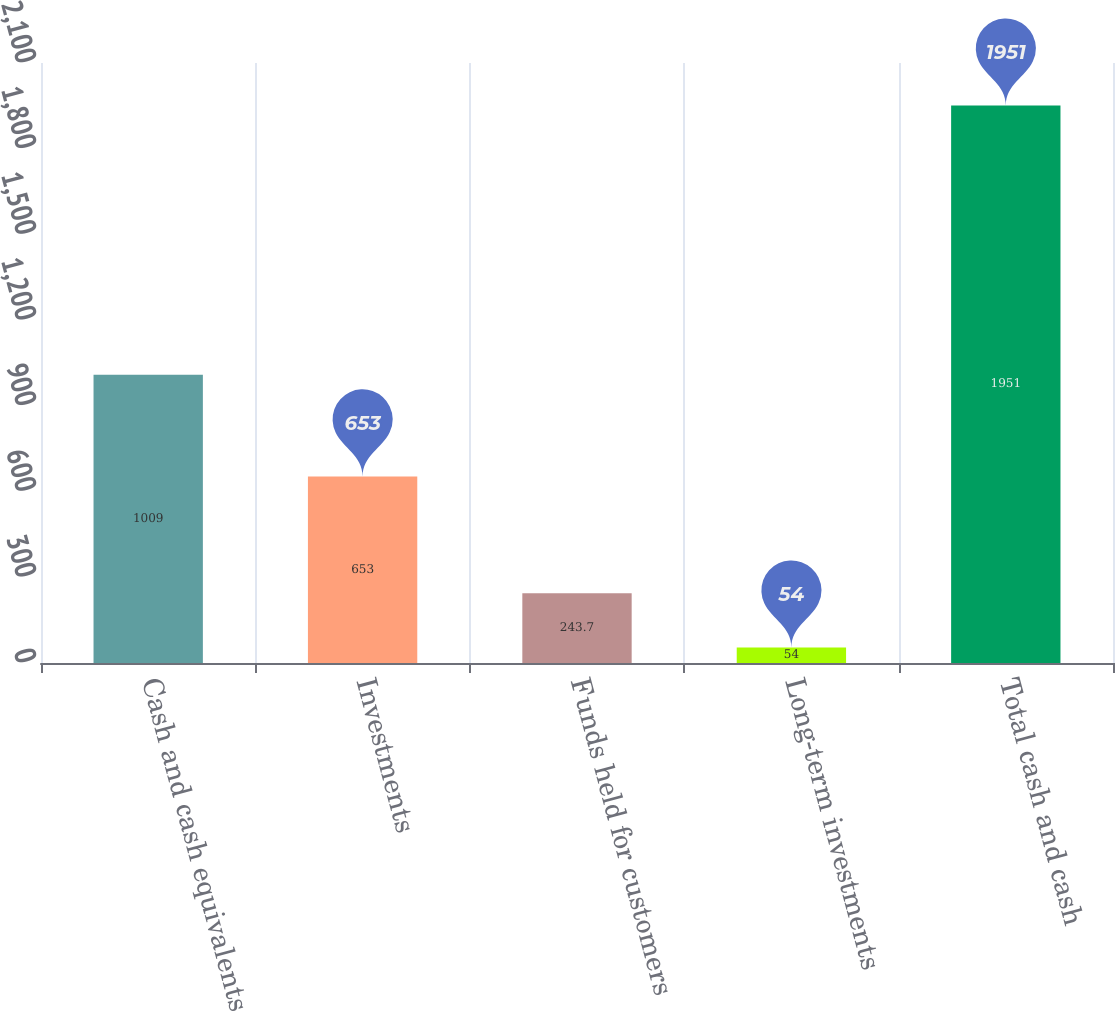<chart> <loc_0><loc_0><loc_500><loc_500><bar_chart><fcel>Cash and cash equivalents<fcel>Investments<fcel>Funds held for customers<fcel>Long-term investments<fcel>Total cash and cash<nl><fcel>1009<fcel>653<fcel>243.7<fcel>54<fcel>1951<nl></chart> 